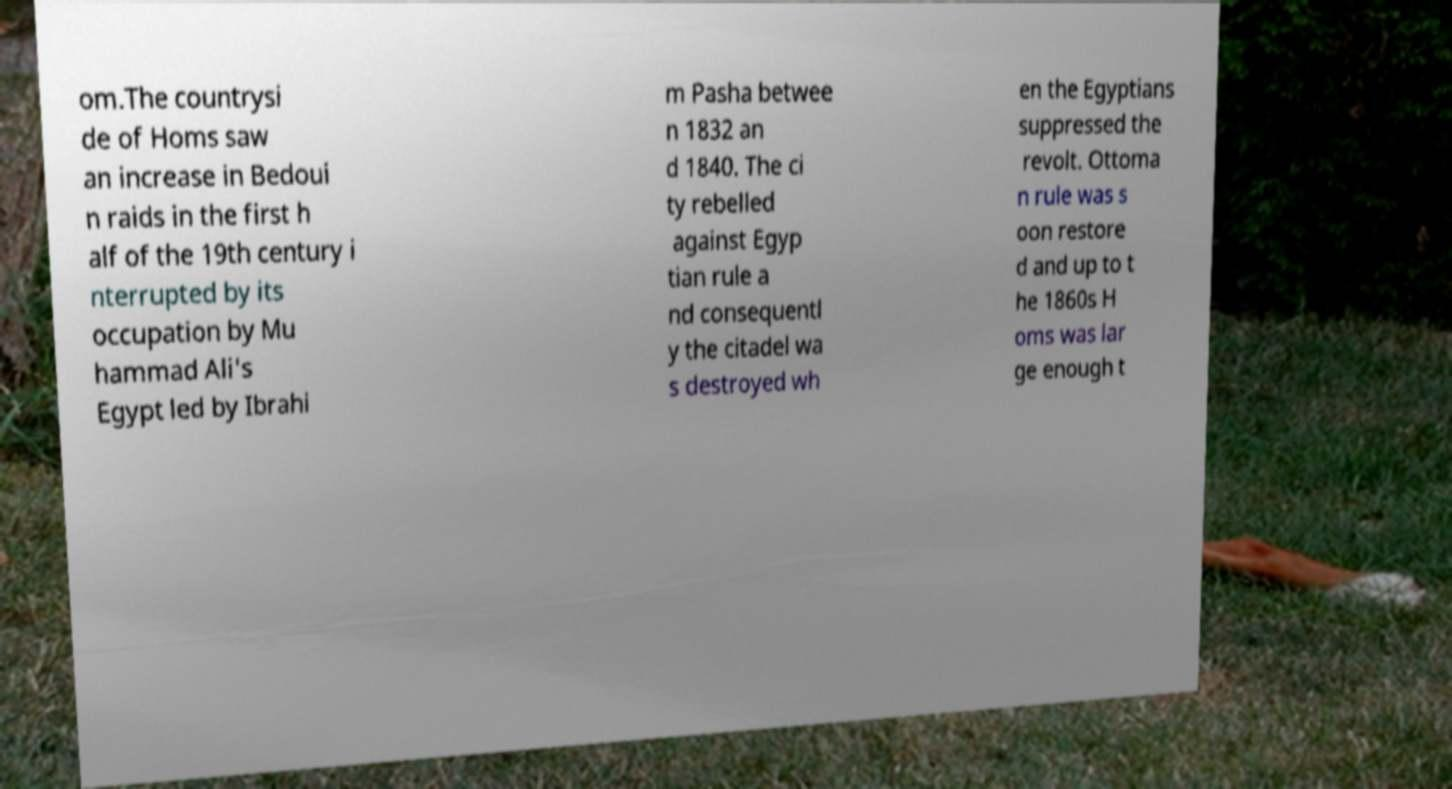Could you assist in decoding the text presented in this image and type it out clearly? om.The countrysi de of Homs saw an increase in Bedoui n raids in the first h alf of the 19th century i nterrupted by its occupation by Mu hammad Ali's Egypt led by Ibrahi m Pasha betwee n 1832 an d 1840. The ci ty rebelled against Egyp tian rule a nd consequentl y the citadel wa s destroyed wh en the Egyptians suppressed the revolt. Ottoma n rule was s oon restore d and up to t he 1860s H oms was lar ge enough t 